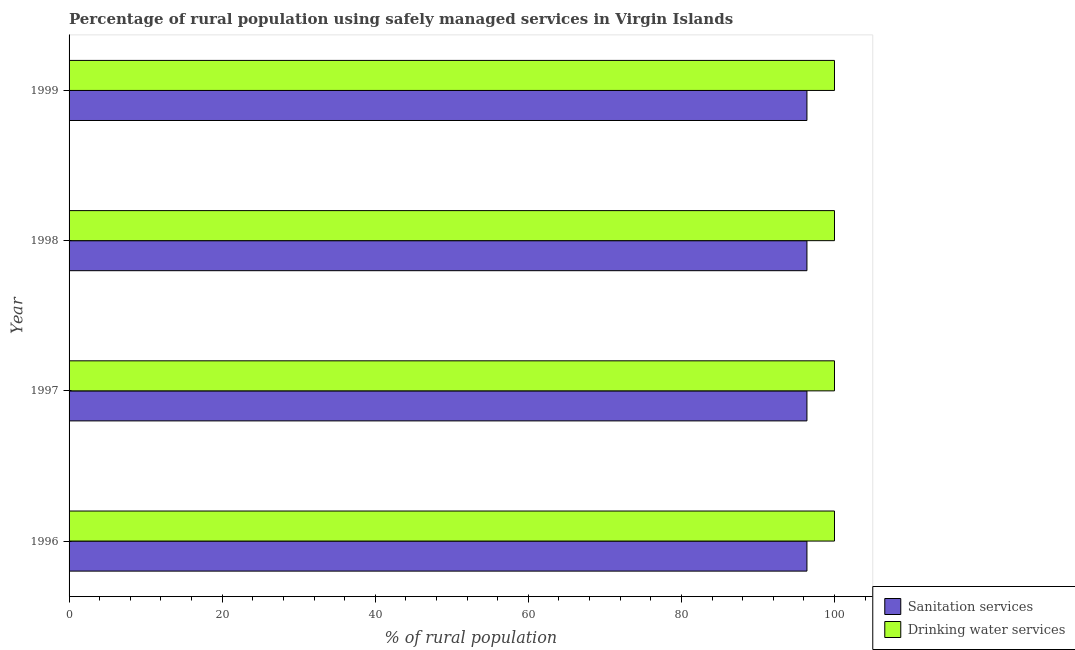How many different coloured bars are there?
Provide a succinct answer. 2. Are the number of bars on each tick of the Y-axis equal?
Provide a succinct answer. Yes. How many bars are there on the 4th tick from the top?
Ensure brevity in your answer.  2. What is the percentage of rural population who used drinking water services in 1998?
Your answer should be compact. 100. Across all years, what is the maximum percentage of rural population who used sanitation services?
Provide a succinct answer. 96.4. Across all years, what is the minimum percentage of rural population who used drinking water services?
Provide a short and direct response. 100. In which year was the percentage of rural population who used sanitation services maximum?
Your answer should be very brief. 1996. What is the total percentage of rural population who used sanitation services in the graph?
Your answer should be compact. 385.6. What is the difference between the percentage of rural population who used drinking water services in 1996 and that in 1998?
Offer a very short reply. 0. What is the difference between the percentage of rural population who used sanitation services in 1998 and the percentage of rural population who used drinking water services in 1996?
Ensure brevity in your answer.  -3.6. What is the average percentage of rural population who used drinking water services per year?
Offer a very short reply. 100. What is the ratio of the percentage of rural population who used drinking water services in 1997 to that in 1998?
Your response must be concise. 1. Is the percentage of rural population who used sanitation services in 1997 less than that in 1999?
Offer a terse response. No. Is the difference between the percentage of rural population who used sanitation services in 1997 and 1998 greater than the difference between the percentage of rural population who used drinking water services in 1997 and 1998?
Your response must be concise. No. Is the sum of the percentage of rural population who used sanitation services in 1996 and 1998 greater than the maximum percentage of rural population who used drinking water services across all years?
Your answer should be very brief. Yes. What does the 2nd bar from the top in 1999 represents?
Ensure brevity in your answer.  Sanitation services. What does the 2nd bar from the bottom in 1998 represents?
Your answer should be compact. Drinking water services. How many years are there in the graph?
Provide a short and direct response. 4. Does the graph contain grids?
Your answer should be compact. No. Where does the legend appear in the graph?
Make the answer very short. Bottom right. How are the legend labels stacked?
Offer a terse response. Vertical. What is the title of the graph?
Provide a short and direct response. Percentage of rural population using safely managed services in Virgin Islands. Does "Primary completion rate" appear as one of the legend labels in the graph?
Provide a succinct answer. No. What is the label or title of the X-axis?
Your answer should be very brief. % of rural population. What is the label or title of the Y-axis?
Ensure brevity in your answer.  Year. What is the % of rural population in Sanitation services in 1996?
Provide a short and direct response. 96.4. What is the % of rural population in Drinking water services in 1996?
Offer a very short reply. 100. What is the % of rural population of Sanitation services in 1997?
Your response must be concise. 96.4. What is the % of rural population in Sanitation services in 1998?
Ensure brevity in your answer.  96.4. What is the % of rural population in Sanitation services in 1999?
Make the answer very short. 96.4. Across all years, what is the maximum % of rural population in Sanitation services?
Your answer should be compact. 96.4. Across all years, what is the maximum % of rural population of Drinking water services?
Make the answer very short. 100. Across all years, what is the minimum % of rural population of Sanitation services?
Provide a short and direct response. 96.4. What is the total % of rural population of Sanitation services in the graph?
Your answer should be very brief. 385.6. What is the total % of rural population of Drinking water services in the graph?
Your answer should be very brief. 400. What is the difference between the % of rural population in Sanitation services in 1996 and that in 1998?
Offer a very short reply. 0. What is the difference between the % of rural population of Drinking water services in 1996 and that in 1998?
Keep it short and to the point. 0. What is the difference between the % of rural population in Drinking water services in 1996 and that in 1999?
Your answer should be compact. 0. What is the difference between the % of rural population of Drinking water services in 1997 and that in 1999?
Your answer should be very brief. 0. What is the difference between the % of rural population of Sanitation services in 1998 and that in 1999?
Offer a terse response. 0. What is the difference between the % of rural population in Sanitation services in 1996 and the % of rural population in Drinking water services in 1999?
Make the answer very short. -3.6. What is the difference between the % of rural population of Sanitation services in 1997 and the % of rural population of Drinking water services in 1999?
Offer a terse response. -3.6. What is the difference between the % of rural population of Sanitation services in 1998 and the % of rural population of Drinking water services in 1999?
Your answer should be compact. -3.6. What is the average % of rural population of Sanitation services per year?
Make the answer very short. 96.4. What is the average % of rural population of Drinking water services per year?
Offer a terse response. 100. In the year 1998, what is the difference between the % of rural population in Sanitation services and % of rural population in Drinking water services?
Offer a very short reply. -3.6. In the year 1999, what is the difference between the % of rural population in Sanitation services and % of rural population in Drinking water services?
Your answer should be compact. -3.6. What is the ratio of the % of rural population in Drinking water services in 1996 to that in 1997?
Offer a terse response. 1. What is the ratio of the % of rural population of Sanitation services in 1996 to that in 1998?
Offer a terse response. 1. What is the ratio of the % of rural population of Drinking water services in 1996 to that in 1999?
Your response must be concise. 1. What is the ratio of the % of rural population of Sanitation services in 1997 to that in 1998?
Make the answer very short. 1. What is the ratio of the % of rural population of Drinking water services in 1997 to that in 1999?
Offer a very short reply. 1. What is the ratio of the % of rural population in Sanitation services in 1998 to that in 1999?
Provide a succinct answer. 1. What is the difference between the highest and the second highest % of rural population in Sanitation services?
Give a very brief answer. 0. 